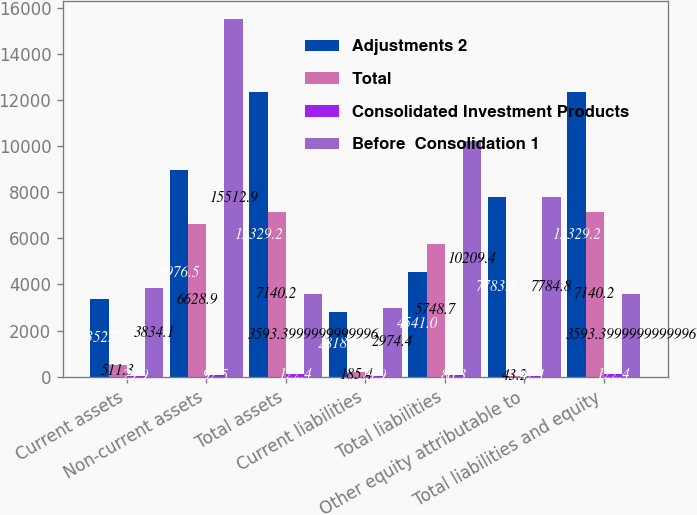Convert chart. <chart><loc_0><loc_0><loc_500><loc_500><stacked_bar_chart><ecel><fcel>Current assets<fcel>Non-current assets<fcel>Total assets<fcel>Current liabilities<fcel>Total liabilities<fcel>Other equity attributable to<fcel>Total liabilities and equity<nl><fcel>Adjustments 2<fcel>3352.7<fcel>8976.5<fcel>12329.2<fcel>2818.9<fcel>4541<fcel>7783.7<fcel>12329.2<nl><fcel>Total<fcel>511.3<fcel>6628.9<fcel>7140.2<fcel>185.4<fcel>5748.7<fcel>43.2<fcel>7140.2<nl><fcel>Consolidated Investment Products<fcel>29.9<fcel>92.5<fcel>122.4<fcel>29.9<fcel>80.3<fcel>42.1<fcel>122.4<nl><fcel>Before  Consolidation 1<fcel>3834.1<fcel>15512.9<fcel>3593.4<fcel>2974.4<fcel>10209.4<fcel>7784.8<fcel>3593.4<nl></chart> 